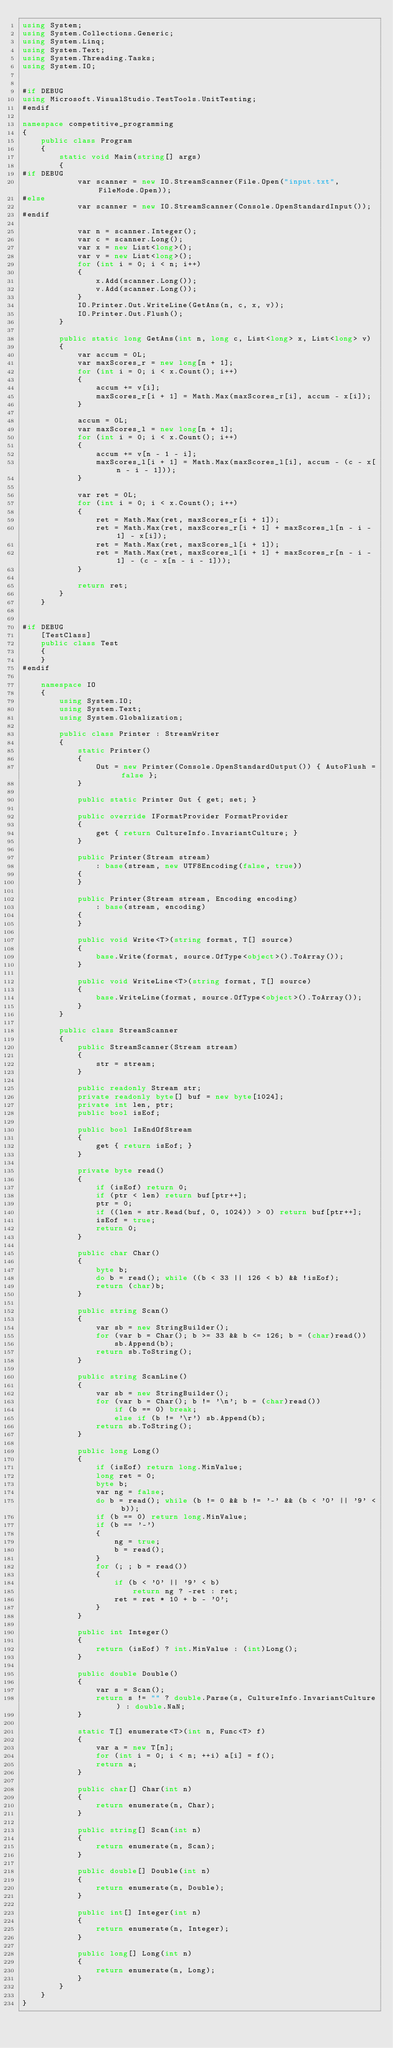<code> <loc_0><loc_0><loc_500><loc_500><_C#_>using System;
using System.Collections.Generic;
using System.Linq;
using System.Text;
using System.Threading.Tasks;
using System.IO;


#if DEBUG
using Microsoft.VisualStudio.TestTools.UnitTesting;
#endif

namespace competitive_programming
{
    public class Program
    {
        static void Main(string[] args)
        {
#if DEBUG
            var scanner = new IO.StreamScanner(File.Open("input.txt", FileMode.Open));
#else
            var scanner = new IO.StreamScanner(Console.OpenStandardInput());
#endif

            var n = scanner.Integer();
            var c = scanner.Long();
            var x = new List<long>();
            var v = new List<long>();
            for (int i = 0; i < n; i++)
            {
                x.Add(scanner.Long());
                v.Add(scanner.Long());
            }
            IO.Printer.Out.WriteLine(GetAns(n, c, x, v));
            IO.Printer.Out.Flush();
        }

        public static long GetAns(int n, long c, List<long> x, List<long> v)
        {
            var accum = 0L;
            var maxScores_r = new long[n + 1];
            for (int i = 0; i < x.Count(); i++)
            {
                accum += v[i];
                maxScores_r[i + 1] = Math.Max(maxScores_r[i], accum - x[i]);
            }

            accum = 0L;
            var maxScores_l = new long[n + 1];
            for (int i = 0; i < x.Count(); i++)
            {
                accum += v[n - 1 - i];
                maxScores_l[i + 1] = Math.Max(maxScores_l[i], accum - (c - x[n - i - 1]));
            }

            var ret = 0L;
            for (int i = 0; i < x.Count(); i++)
            {
                ret = Math.Max(ret, maxScores_r[i + 1]);
                ret = Math.Max(ret, maxScores_r[i + 1] + maxScores_l[n - i - 1] - x[i]);
                ret = Math.Max(ret, maxScores_l[i + 1]);
                ret = Math.Max(ret, maxScores_l[i + 1] + maxScores_r[n - i - 1] - (c - x[n - i - 1]));
            }

            return ret;
        }
    }


#if DEBUG
    [TestClass]
    public class Test
    {
    }
#endif

    namespace IO
    {
        using System.IO;
        using System.Text;
        using System.Globalization;

        public class Printer : StreamWriter
        {
            static Printer()
            {
                Out = new Printer(Console.OpenStandardOutput()) { AutoFlush = false };
            }

            public static Printer Out { get; set; }

            public override IFormatProvider FormatProvider
            {
                get { return CultureInfo.InvariantCulture; }
            }

            public Printer(Stream stream)
                : base(stream, new UTF8Encoding(false, true))
            {
            }

            public Printer(Stream stream, Encoding encoding)
                : base(stream, encoding)
            {
            }

            public void Write<T>(string format, T[] source)
            {
                base.Write(format, source.OfType<object>().ToArray());
            }

            public void WriteLine<T>(string format, T[] source)
            {
                base.WriteLine(format, source.OfType<object>().ToArray());
            }
        }

        public class StreamScanner
        {
            public StreamScanner(Stream stream)
            {
                str = stream;
            }

            public readonly Stream str;
            private readonly byte[] buf = new byte[1024];
            private int len, ptr;
            public bool isEof;

            public bool IsEndOfStream
            {
                get { return isEof; }
            }

            private byte read()
            {
                if (isEof) return 0;
                if (ptr < len) return buf[ptr++];
                ptr = 0;
                if ((len = str.Read(buf, 0, 1024)) > 0) return buf[ptr++];
                isEof = true;
                return 0;
            }

            public char Char()
            {
                byte b;
                do b = read(); while ((b < 33 || 126 < b) && !isEof);
                return (char)b;
            }

            public string Scan()
            {
                var sb = new StringBuilder();
                for (var b = Char(); b >= 33 && b <= 126; b = (char)read())
                    sb.Append(b);
                return sb.ToString();
            }

            public string ScanLine()
            {
                var sb = new StringBuilder();
                for (var b = Char(); b != '\n'; b = (char)read())
                    if (b == 0) break;
                    else if (b != '\r') sb.Append(b);
                return sb.ToString();
            }

            public long Long()
            {
                if (isEof) return long.MinValue;
                long ret = 0;
                byte b;
                var ng = false;
                do b = read(); while (b != 0 && b != '-' && (b < '0' || '9' < b));
                if (b == 0) return long.MinValue;
                if (b == '-')
                {
                    ng = true;
                    b = read();
                }
                for (; ; b = read())
                {
                    if (b < '0' || '9' < b)
                        return ng ? -ret : ret;
                    ret = ret * 10 + b - '0';
                }
            }

            public int Integer()
            {
                return (isEof) ? int.MinValue : (int)Long();
            }

            public double Double()
            {
                var s = Scan();
                return s != "" ? double.Parse(s, CultureInfo.InvariantCulture) : double.NaN;
            }

            static T[] enumerate<T>(int n, Func<T> f)
            {
                var a = new T[n];
                for (int i = 0; i < n; ++i) a[i] = f();
                return a;
            }

            public char[] Char(int n)
            {
                return enumerate(n, Char);
            }

            public string[] Scan(int n)
            {
                return enumerate(n, Scan);
            }

            public double[] Double(int n)
            {
                return enumerate(n, Double);
            }

            public int[] Integer(int n)
            {
                return enumerate(n, Integer);
            }

            public long[] Long(int n)
            {
                return enumerate(n, Long);
            }
        }
    }
}</code> 